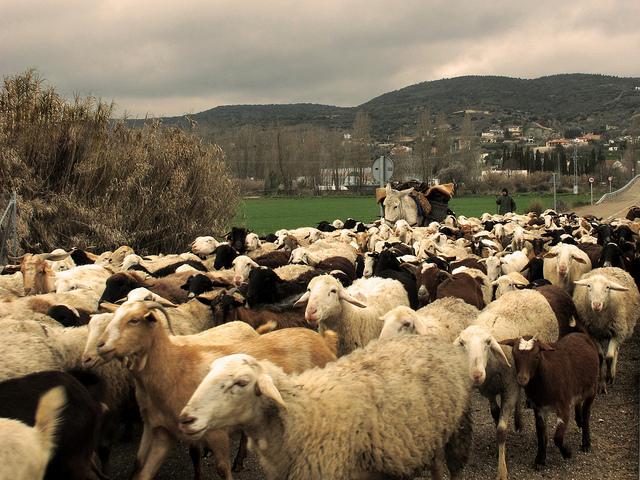Did these sheep climb to the top of this mountain?
Concise answer only. Yes. How many sheep are there?
Write a very short answer. 50. Are the sheep in the road?
Write a very short answer. Yes. Is it raining?
Be succinct. No. 